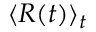Convert formula to latex. <formula><loc_0><loc_0><loc_500><loc_500>\langle R ( t ) \rangle _ { t }</formula> 